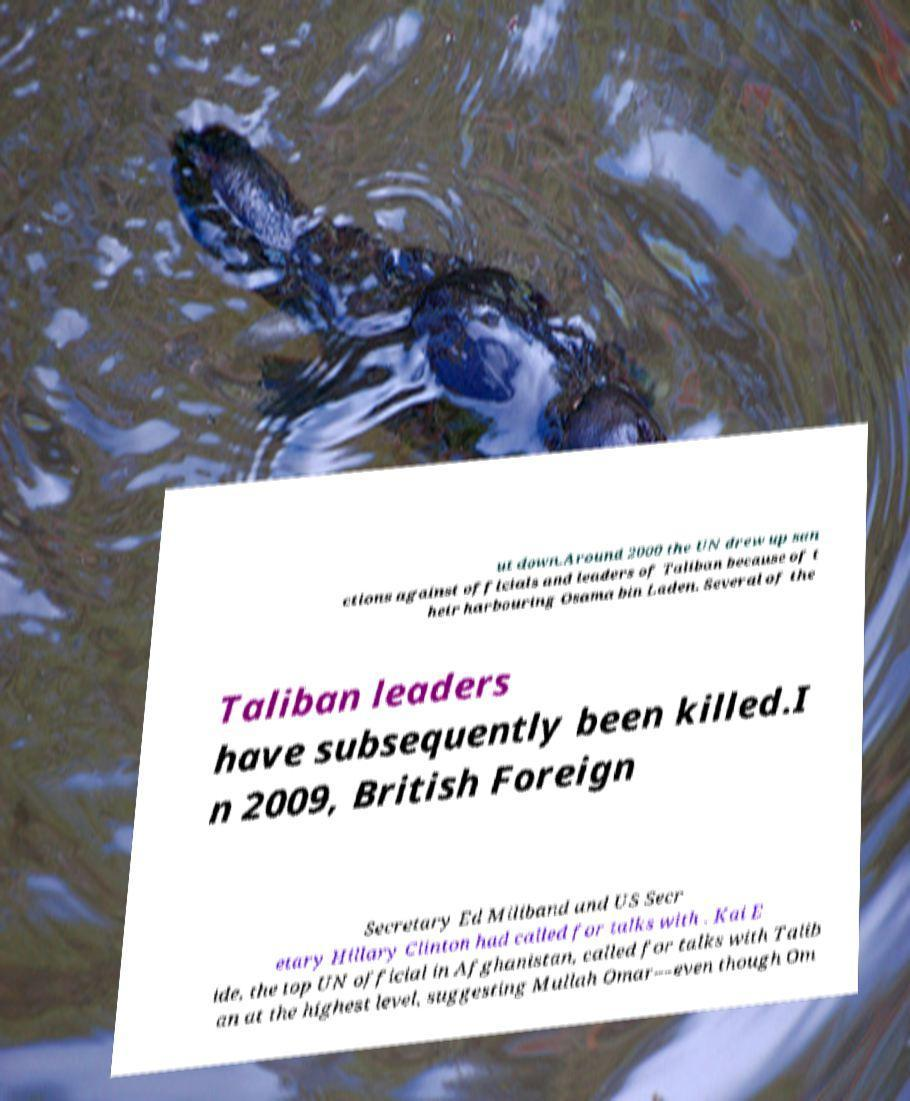There's text embedded in this image that I need extracted. Can you transcribe it verbatim? ut down.Around 2000 the UN drew up san ctions against officials and leaders of Taliban because of t heir harbouring Osama bin Laden. Several of the Taliban leaders have subsequently been killed.I n 2009, British Foreign Secretary Ed Miliband and US Secr etary Hillary Clinton had called for talks with . Kai E ide, the top UN official in Afghanistan, called for talks with Talib an at the highest level, suggesting Mullah Omar—even though Om 